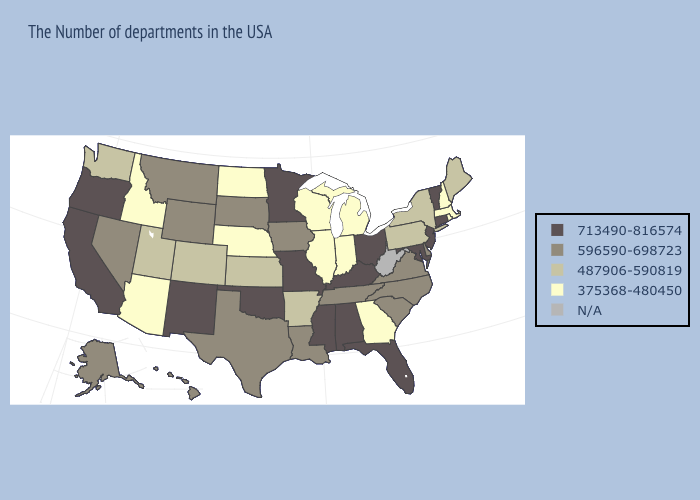Among the states that border Pennsylvania , which have the highest value?
Give a very brief answer. New Jersey, Maryland, Ohio. What is the lowest value in the Northeast?
Concise answer only. 375368-480450. Name the states that have a value in the range 596590-698723?
Write a very short answer. Delaware, Virginia, North Carolina, South Carolina, Tennessee, Louisiana, Iowa, Texas, South Dakota, Wyoming, Montana, Nevada, Alaska, Hawaii. How many symbols are there in the legend?
Write a very short answer. 5. Which states have the lowest value in the USA?
Short answer required. Massachusetts, Rhode Island, New Hampshire, Georgia, Michigan, Indiana, Wisconsin, Illinois, Nebraska, North Dakota, Arizona, Idaho. Does the first symbol in the legend represent the smallest category?
Answer briefly. No. Name the states that have a value in the range 713490-816574?
Quick response, please. Vermont, Connecticut, New Jersey, Maryland, Ohio, Florida, Kentucky, Alabama, Mississippi, Missouri, Minnesota, Oklahoma, New Mexico, California, Oregon. Among the states that border Washington , which have the lowest value?
Write a very short answer. Idaho. What is the lowest value in states that border New Hampshire?
Give a very brief answer. 375368-480450. What is the value of Oklahoma?
Be succinct. 713490-816574. Among the states that border Kansas , which have the highest value?
Answer briefly. Missouri, Oklahoma. Which states have the lowest value in the USA?
Concise answer only. Massachusetts, Rhode Island, New Hampshire, Georgia, Michigan, Indiana, Wisconsin, Illinois, Nebraska, North Dakota, Arizona, Idaho. 